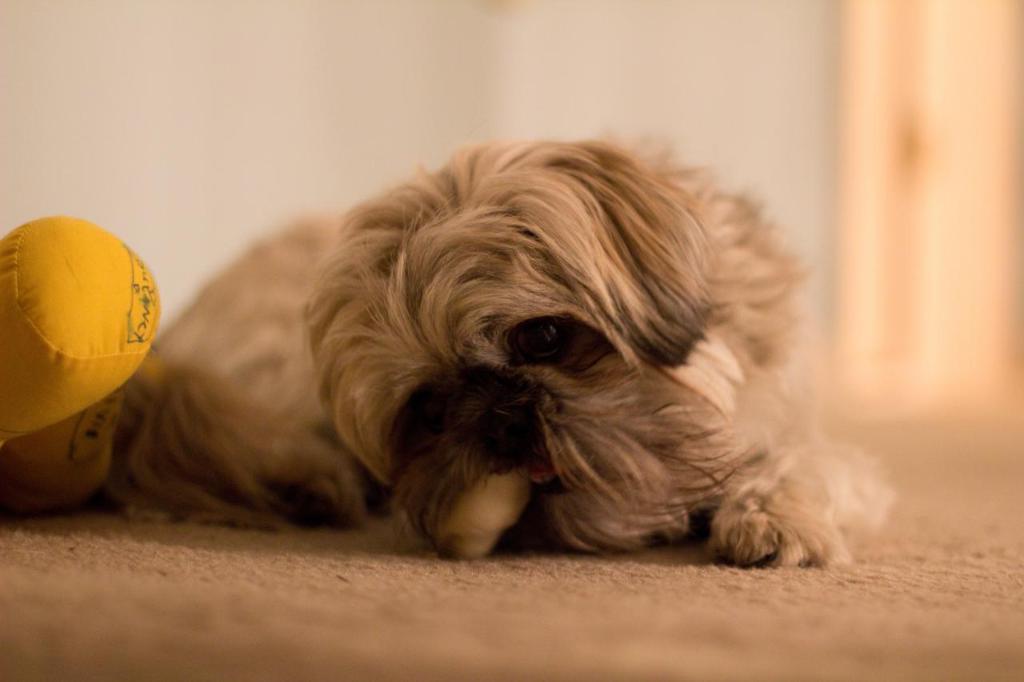Could you give a brief overview of what you see in this image? In this image we can see a dog which is in brown color and there is a doll which is yellow in color on left side of the image. 